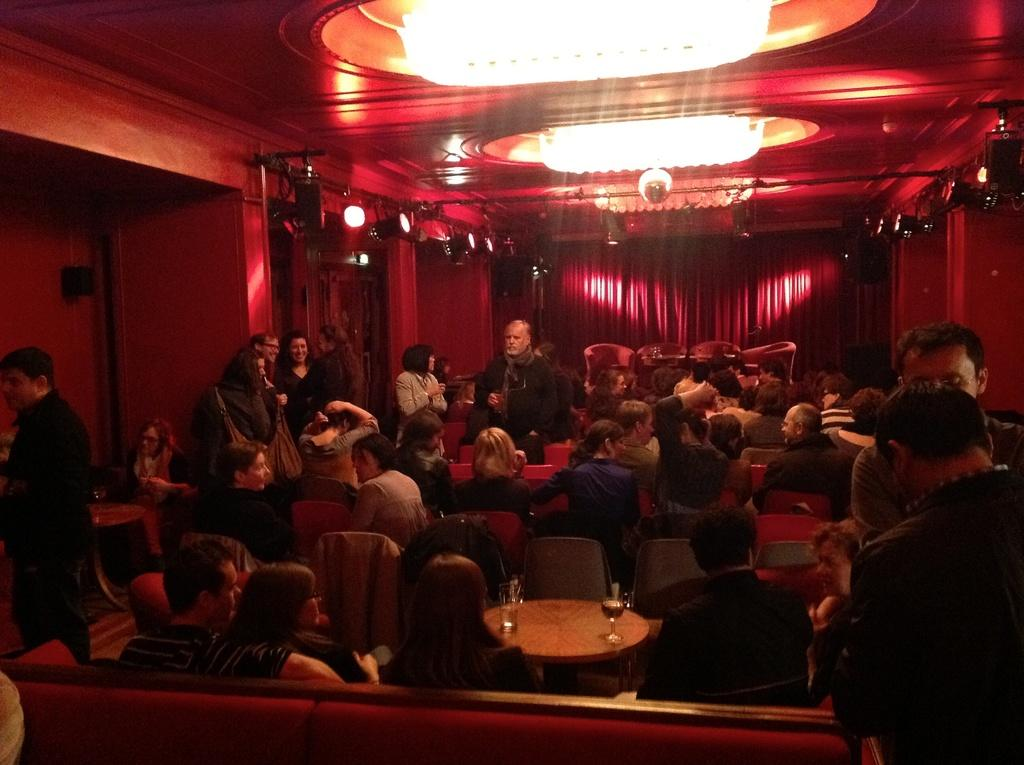What are the people in the image doing? There are people sitting in chairs and people standing beside the seated people. Can you describe the location of the lights in the image? The lights are on the roof. How are the people sorting the bananas in the image? There are no bananas present in the image, so it is not possible to determine how the people might be sorting them. 